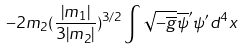<formula> <loc_0><loc_0><loc_500><loc_500>- 2 m _ { 2 } ( \frac { | m _ { 1 } | } { 3 | m _ { 2 } | } ) ^ { 3 / 2 } \int \sqrt { - \overline { g } } \overline { \psi } ^ { \prime } \psi ^ { \prime } d ^ { 4 } x</formula> 